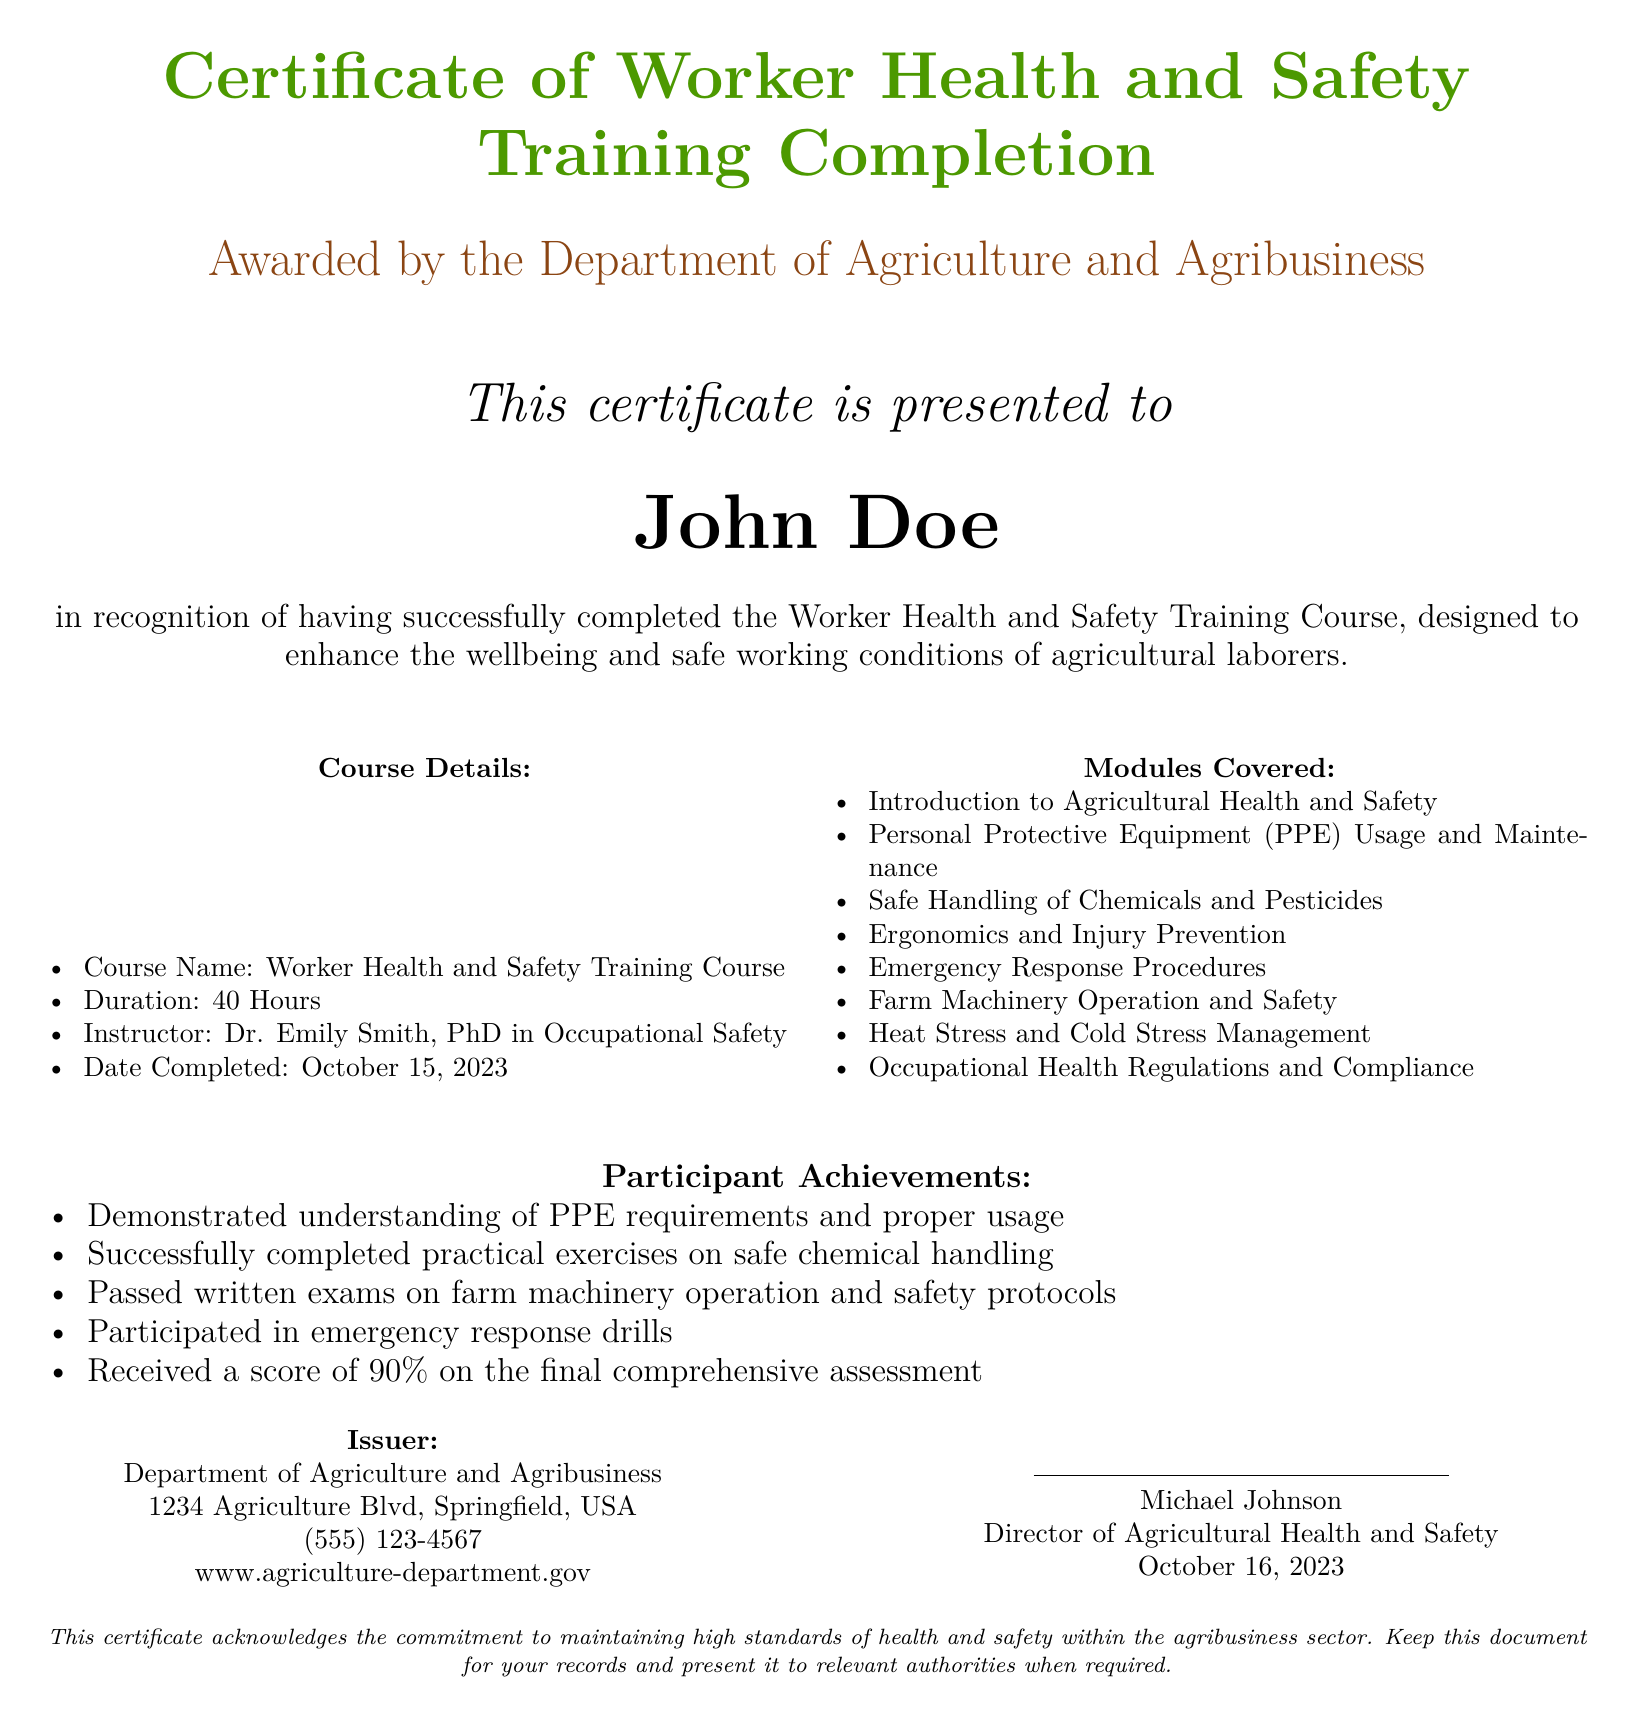What is the name of the course? The course name is explicitly stated in the document under Course Details.
Answer: Worker Health and Safety Training Course Who awarded the certificate? The document specifies that the certificate is awarded by the Department of Agriculture and Agribusiness.
Answer: Department of Agriculture and Agribusiness What was the date of course completion? The completion date is provided in the Course Details section of the document.
Answer: October 15, 2023 What is the score received on the final assessment? The score for the final assessment is mentioned in the Participant Achievements section.
Answer: 90% Who is the instructor of the course? The instructor's name is listed in the Course Details section.
Answer: Dr. Emily Smith How many hours did the training course last? The duration of the training course is specified in the Course Details.
Answer: 40 Hours What is the purpose of the training course? The purpose is described in the introductory statement of the document.
Answer: Enhance the wellbeing and safe working conditions What should participants do with this certificate? The document provides guidance on what to do with the certificate in the final statement.
Answer: Keep this document for your records 